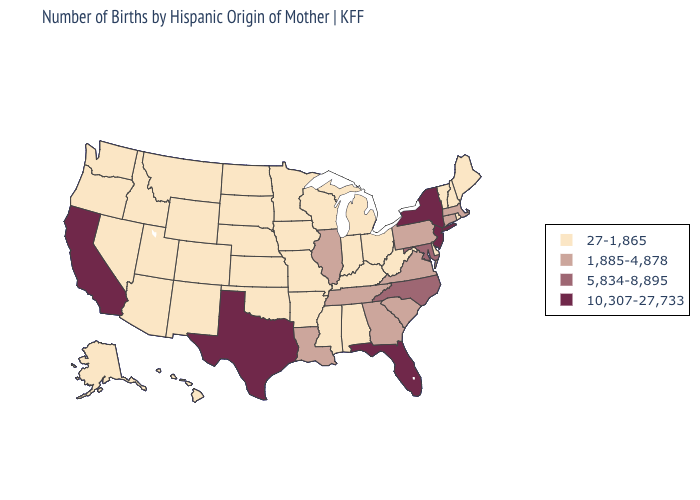Does the first symbol in the legend represent the smallest category?
Concise answer only. Yes. Among the states that border New Mexico , which have the highest value?
Keep it brief. Texas. What is the lowest value in the USA?
Concise answer only. 27-1,865. Which states have the lowest value in the South?
Keep it brief. Alabama, Arkansas, Delaware, Kentucky, Mississippi, Oklahoma, West Virginia. Among the states that border Missouri , does Illinois have the lowest value?
Give a very brief answer. No. What is the value of Colorado?
Short answer required. 27-1,865. What is the value of Maryland?
Keep it brief. 5,834-8,895. Does the first symbol in the legend represent the smallest category?
Keep it brief. Yes. What is the value of New York?
Be succinct. 10,307-27,733. Among the states that border Florida , which have the highest value?
Write a very short answer. Georgia. Does Georgia have a lower value than California?
Answer briefly. Yes. Name the states that have a value in the range 10,307-27,733?
Be succinct. California, Florida, New Jersey, New York, Texas. Among the states that border Tennessee , which have the highest value?
Short answer required. North Carolina. Which states have the lowest value in the USA?
Answer briefly. Alabama, Alaska, Arizona, Arkansas, Colorado, Delaware, Hawaii, Idaho, Indiana, Iowa, Kansas, Kentucky, Maine, Michigan, Minnesota, Mississippi, Missouri, Montana, Nebraska, Nevada, New Hampshire, New Mexico, North Dakota, Ohio, Oklahoma, Oregon, Rhode Island, South Dakota, Utah, Vermont, Washington, West Virginia, Wisconsin, Wyoming. 